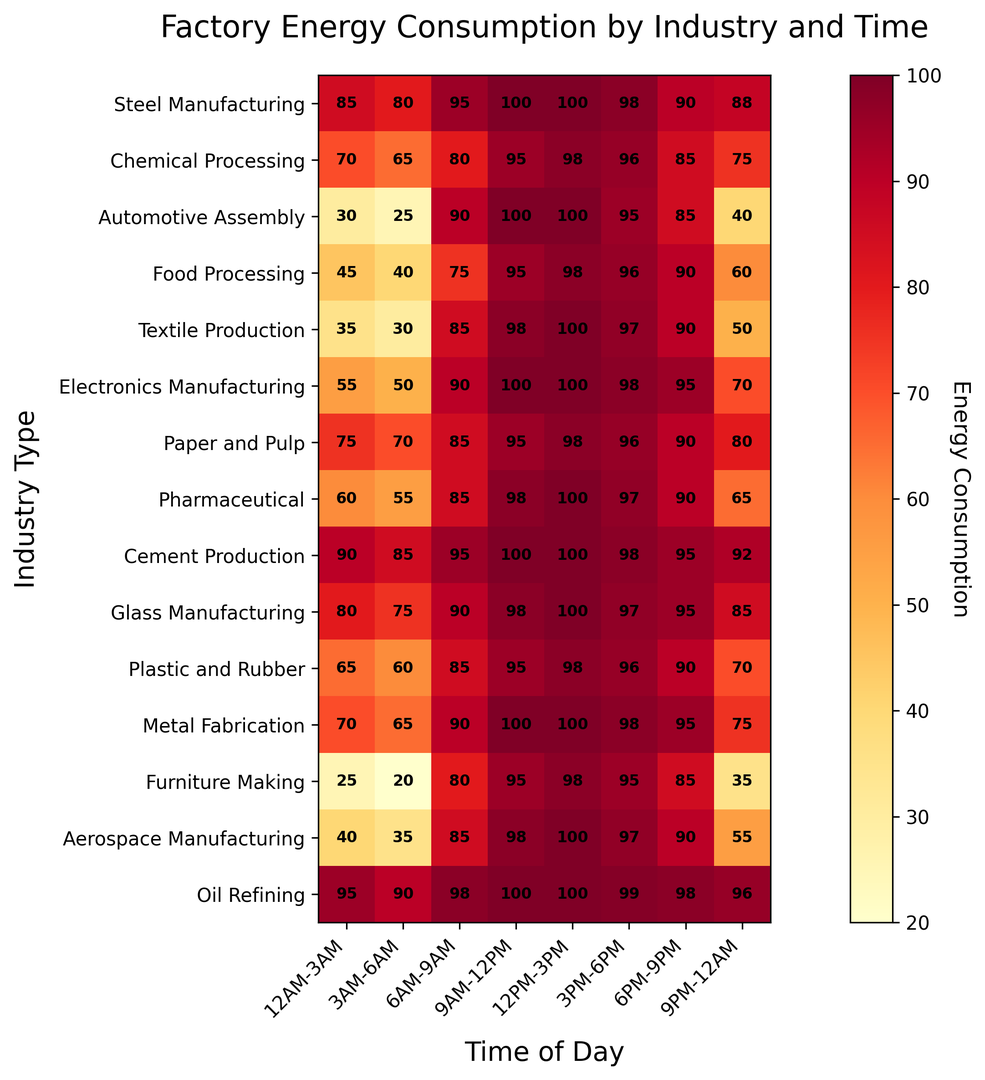What is the highest energy consumption recorded for Oil Refining? To find the highest energy consumption for Oil Refining, locate the 'Oil Refining' row in the heatmap and find the maximum value among the time slots, which is 100.
Answer: 100 Which industry has the lowest energy consumption between 12AM-3AM? Identify the lowest value in the first column (12AM-3AM). It's 25 for Furniture Making.
Answer: Furniture Making During which time slot does Electronics Manufacturing consume the most energy? Find the row for Electronics Manufacturing and identify the maximum value. The peak value, 100, appears in the 6AM-9AM, 9AM-12PM, and 12PM-3PM slots.
Answer: 6AM-9AM, 9AM-12PM, 12PM-3PM What is the total energy consumption for Furniture Making throughout the day? Sum the values of the Furniture Making row: 25 + 20 + 80 + 95 + 98 + 95 + 85 + 35 = 533.
Answer: 533 How does the energy consumption of Chemical Processing from 3PM-6PM compare to that of Plastic and Rubber at the same time? Locate the value for Chemical Processing (96) and Plastic and Rubber (96) in the 3PM-6PM column; both figures are equal.
Answer: Equal Which time slot generally displays the highest energy consumption for most industries? Examine the heatmap for the time slot with the highest concentration of dark red colors. The 12PM-3PM slot often shows darker red, indicating high consumption.
Answer: 12PM-3PM If we average the energy consumption of Steel Manufacturing between 12PM-3PM and 3PM-6PM, what do we get? Calculate the average of the values in the 12PM-3PM and 3PM-6PM slots for Steel Manufacturing: (100 + 98) / 2 = 99.
Answer: 99 Does Textiles Production have a higher energy consumption at 6AM-9AM or 9PM-12AM? Compare the values for Textiles Production in the 6AM-9AM (85) and 9PM-12AM (50) slots. It is higher at 6AM-9AM.
Answer: 6AM-9AM Which industry shows the most significant increase in energy consumption from 12AM-3AM to 9AM-12PM? Calculate the difference between 12AM-3AM and 9AM-12PM for each industry. Automotive Assembly has a difference of 100 - 30 = 70.
Answer: Automotive Assembly 